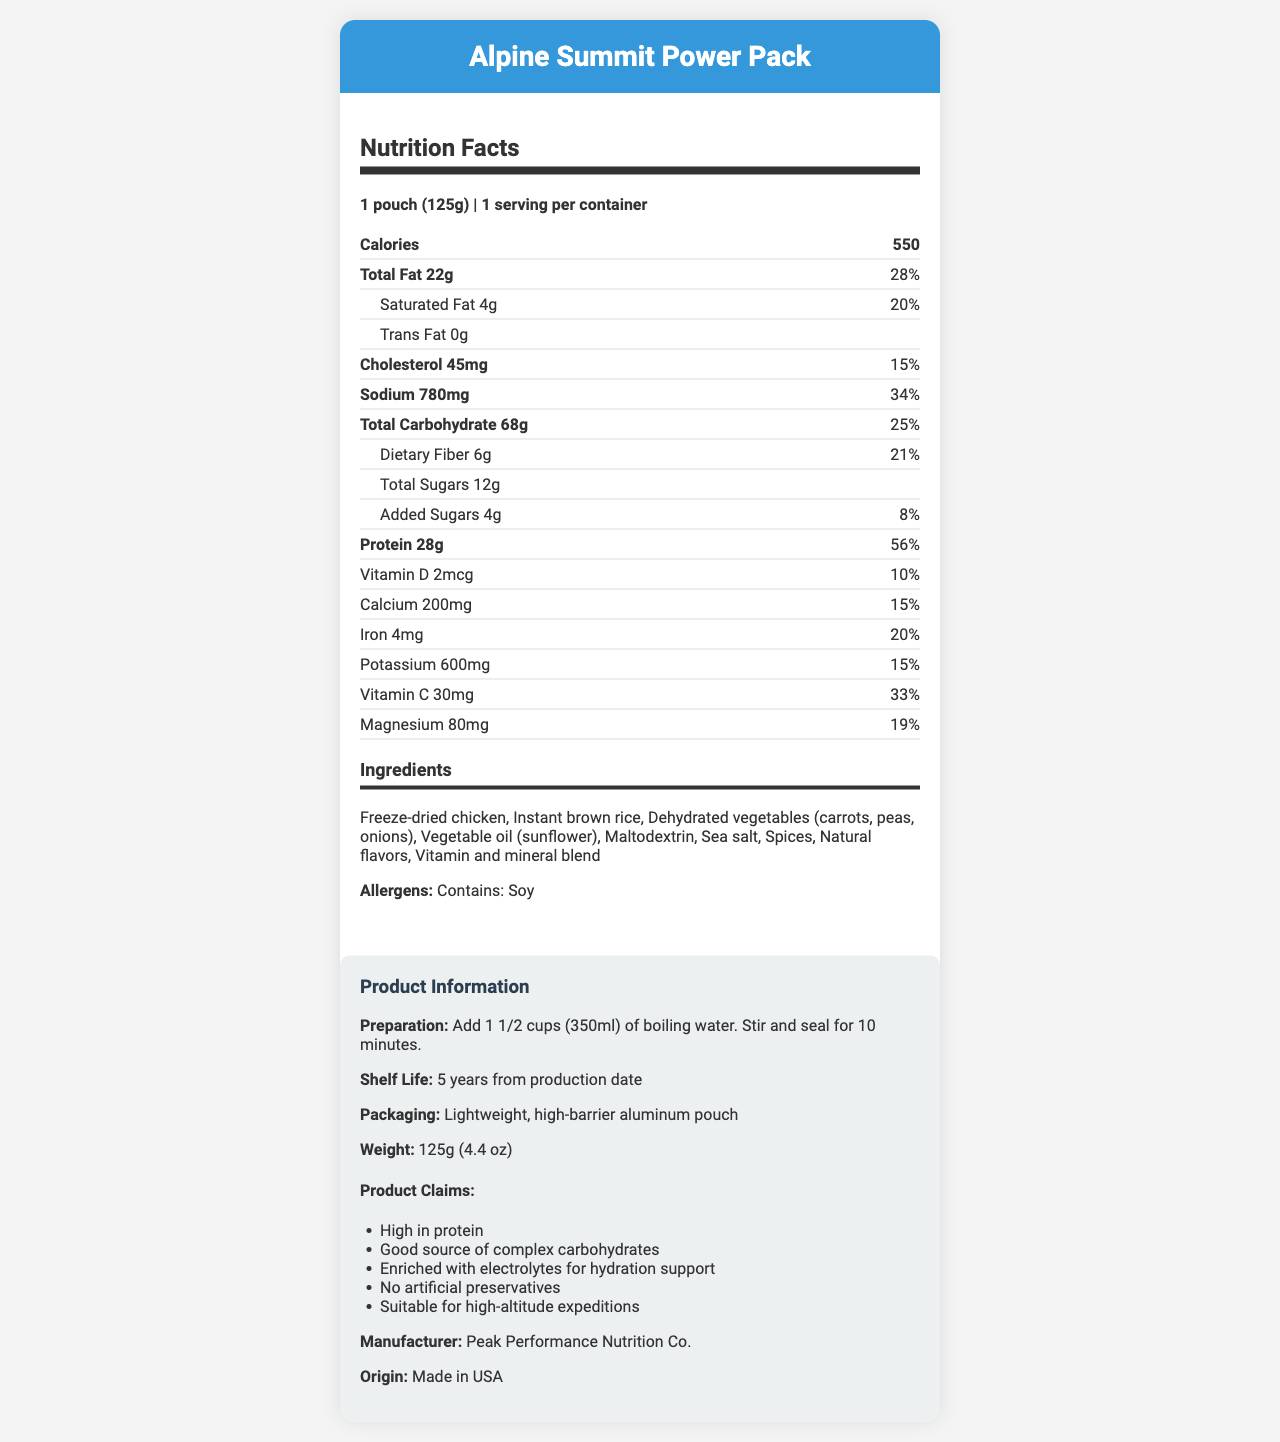what is the serving size of the Alpine Summit Power Pack? The serving size is given as "1 pouch (125g)" in the document.
Answer: 1 pouch (125g) how many calories are in the Alpine Summit Power Pack? The number of calories is listed as 550 in the nutrition facts.
Answer: 550 what is the daily value percentage of total fat? The daily value percentage for total fat is specified as 28%.
Answer: 28% what are the main ingredients of the Alpine Summit Power Pack? The main ingredients are listed under the ingredients section in the document.
Answer: Freeze-dried chicken, Instant brown rice, Dehydrated vegetables (carrots, peas, onions), Vegetable oil (sunflower), Maltodextrin, Sea salt, Spices, Natural flavors, Vitamin and mineral blend what is the shelf life of the product? The shelf life is given as "5 years from production date."
Answer: 5 years from production date What is the amount of dietary fiber per serving? The amount of dietary fiber per serving is specified as 6g.
Answer: 6g Is the product high in protein? The document claims that the product is "High in protein."
Answer: Yes how much sodium does one serving contain? The sodium content per serving is listed as 780 mg.
Answer: 780 mg which of the following nutrients is not mentioned in the document? A. Vitamin A B. Vitamin D C. Vitamin C D. Calcium Vitamin A is not mentioned in the nutrition facts, while Vitamin D, Vitamin C, and Calcium are listed.
Answer: A. Vitamin A how much added sugars does one serving contain? A. 2g B. 4g C. 6g D. 8g The document states that each serving contains 4g of added sugars.
Answer: B. 4g what is the packaging type of the Alpine Summit Power Pack? The packaging type is described as "Lightweight, high-barrier aluminum pouch."
Answer: Lightweight, high-barrier aluminum pouch Can the product be used for high-altitude expeditions? The document claims that the product is "Suitable for high-altitude expeditions."
Answer: Yes How should the product be prepared? The preparation instructions mentioned are to add 1 1/2 cups (350ml) of boiling water, stir and seal for 10 minutes.
Answer: Add 1 1/2 cups (350ml) of boiling water. Stir and seal for 10 minutes. Summarize the main features and nutritional highlights of the Alpine Summit Power Pack. The summary covers the nutritional highlights, main ingredients, packaging details, and product claims as described in the document.
Answer: The Alpine Summit Power Pack is a freeze-dried meal designed for mountaineering, providing 550 calories per serving with 28g of protein. It includes ingredients like freeze-dried chicken and instant brown rice, and contains 6g of dietary fiber and 12g of sugars (including 4g added sugars). The product is high in electrolytes and complex carbohydrates, contains no artificial preservatives, and is packed in a lightweight, high-barrier aluminum pouch with a shelf life of 5 years. It's suitable for high-altitude expeditions. what percentage of daily value does the magnesium content represent? The document states that the magnesium content represents 19% of the daily value.
Answer: 19% what is the weight of the product? The weight is specified as 125g (4.4 oz) in the product information section.
Answer: 125g (4.4 oz) Who manufactures the Alpine Summit Power Pack? The manufacturer is listed as Peak Performance Nutrition Co.
Answer: Peak Performance Nutrition Co. Are there any allergens present in the product? The document mentions that the product contains soy as an allergen.
Answer: Yes, contains soy What is the price of the Alpine Summit Power Pack? The document does not provide any information regarding the price of the product.
Answer: Cannot be determined 